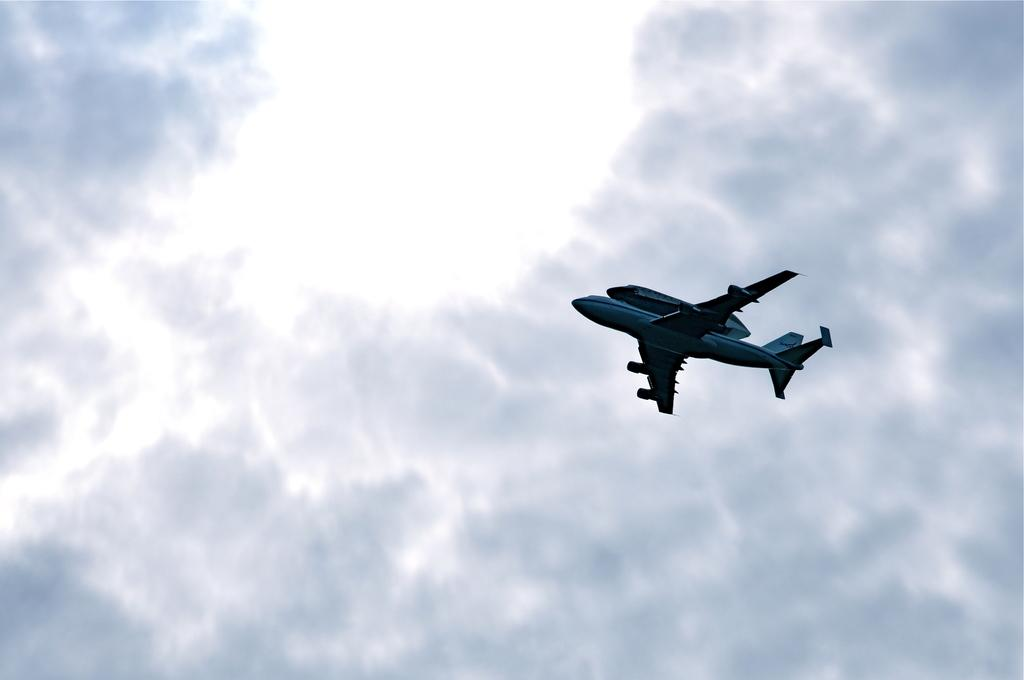What can be seen in the background of the image? The sky is visible in the background of the image. What is flying in the air in the image? There is a plane in the air in the image. Where is the cat hiding in the image? There is no cat present in the image. Is the honey being harvested from the plane in the image? There is no honey or honey harvesting activity depicted in the image. 